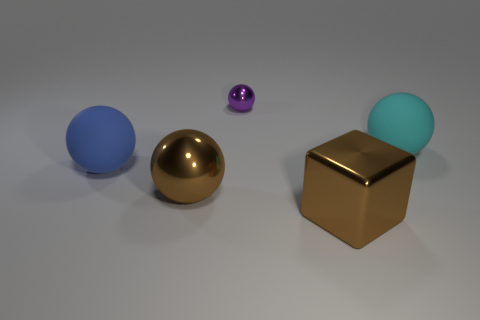Add 1 big matte spheres. How many objects exist? 6 Subtract all tiny purple metal spheres. How many spheres are left? 3 Subtract all cyan balls. How many balls are left? 3 Subtract all blocks. How many objects are left? 4 Add 4 brown balls. How many brown balls exist? 5 Subtract 1 brown spheres. How many objects are left? 4 Subtract all purple balls. Subtract all gray cylinders. How many balls are left? 3 Subtract all purple cylinders. How many purple cubes are left? 0 Subtract all tiny green cylinders. Subtract all brown metal balls. How many objects are left? 4 Add 1 metallic objects. How many metallic objects are left? 4 